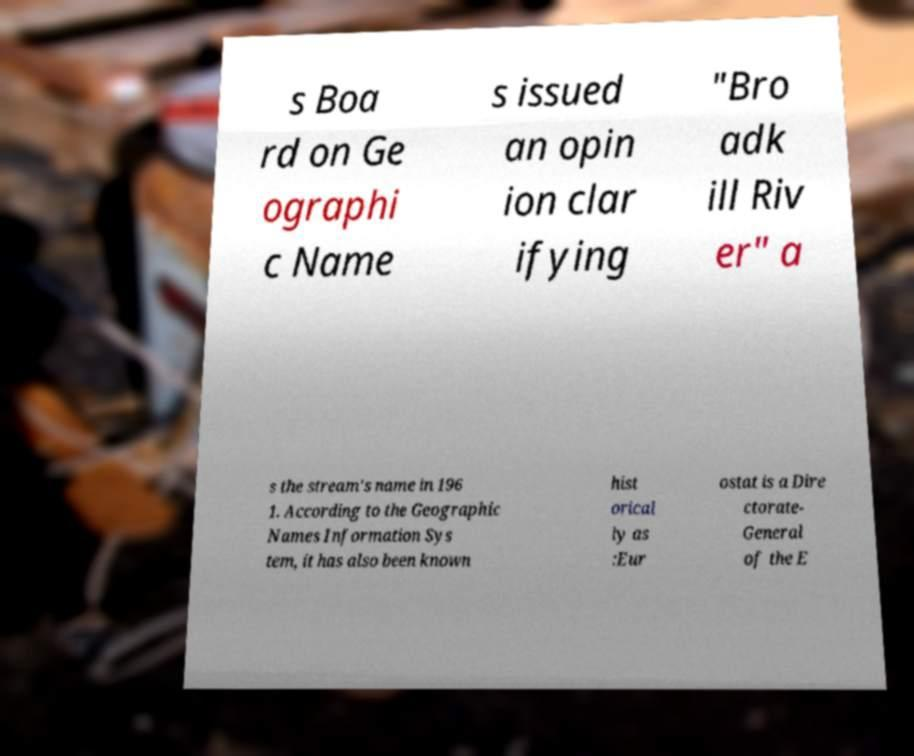There's text embedded in this image that I need extracted. Can you transcribe it verbatim? s Boa rd on Ge ographi c Name s issued an opin ion clar ifying "Bro adk ill Riv er" a s the stream's name in 196 1. According to the Geographic Names Information Sys tem, it has also been known hist orical ly as :Eur ostat is a Dire ctorate- General of the E 